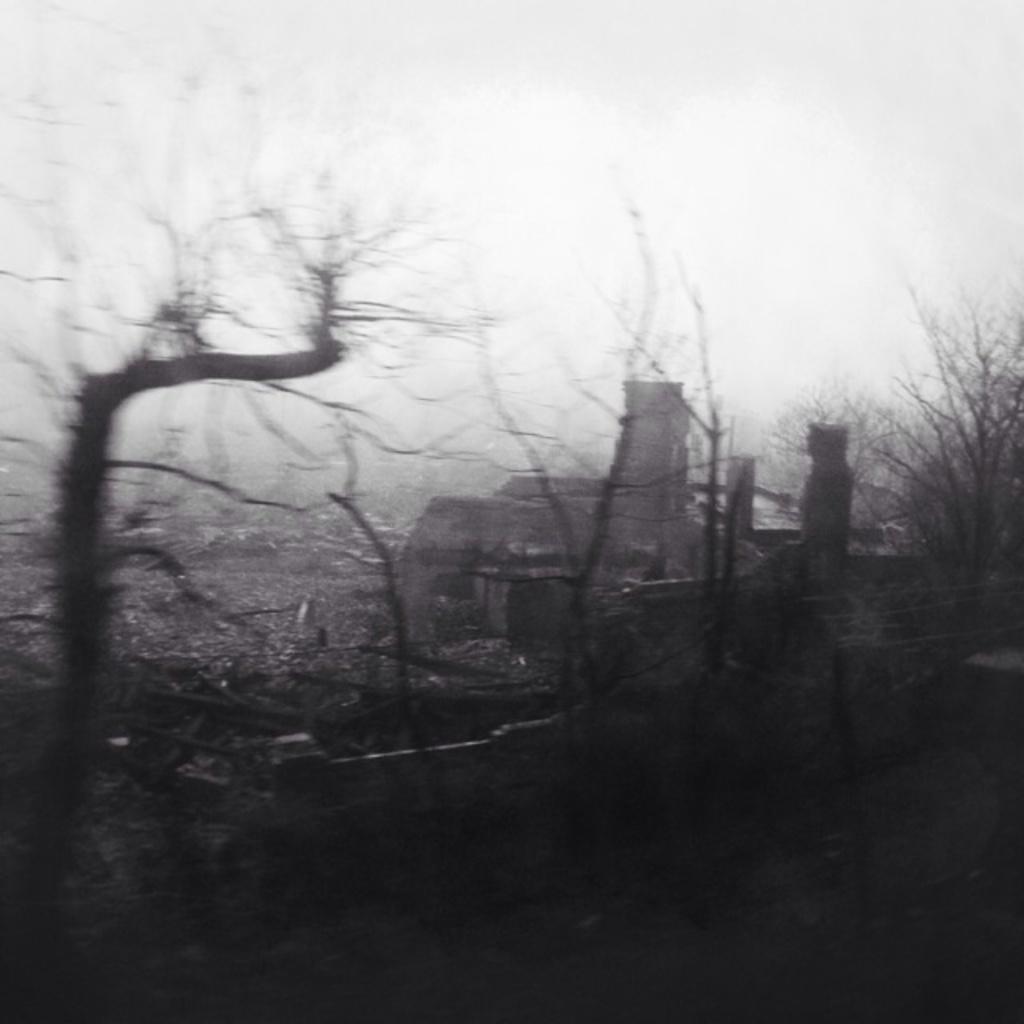In one or two sentences, can you explain what this image depicts? In the picture I can see trees, a building and the sky. This picture is black and white in color. 